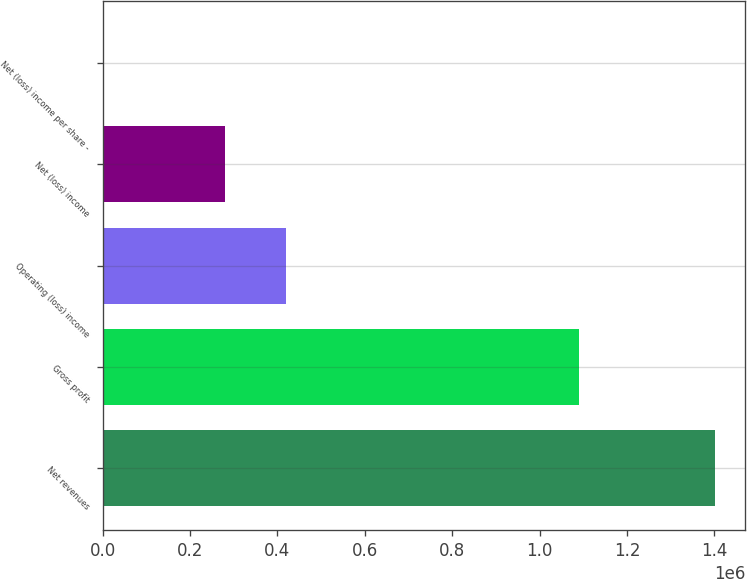Convert chart to OTSL. <chart><loc_0><loc_0><loc_500><loc_500><bar_chart><fcel>Net revenues<fcel>Gross profit<fcel>Operating (loss) income<fcel>Net (loss) income<fcel>Net (loss) income per share -<nl><fcel>1.40034e+06<fcel>1.09007e+06<fcel>420101<fcel>280068<fcel>0.1<nl></chart> 